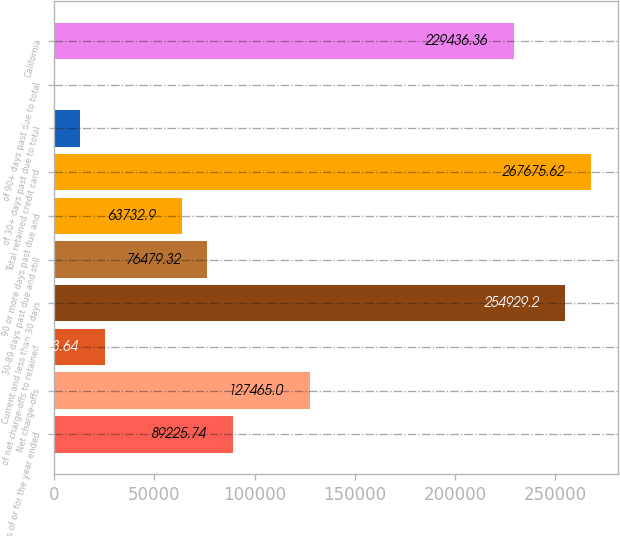Convert chart. <chart><loc_0><loc_0><loc_500><loc_500><bar_chart><fcel>As of or for the year ended<fcel>Net charge-offs<fcel>of net charge-offs to retained<fcel>Current and less than 30 days<fcel>30-89 days past due and still<fcel>90 or more days past due and<fcel>Total retained credit card<fcel>of 30+ days past due to total<fcel>of 90+ days past due to total<fcel>California<nl><fcel>89225.7<fcel>127465<fcel>25493.6<fcel>254929<fcel>76479.3<fcel>63732.9<fcel>267676<fcel>12747.2<fcel>0.8<fcel>229436<nl></chart> 